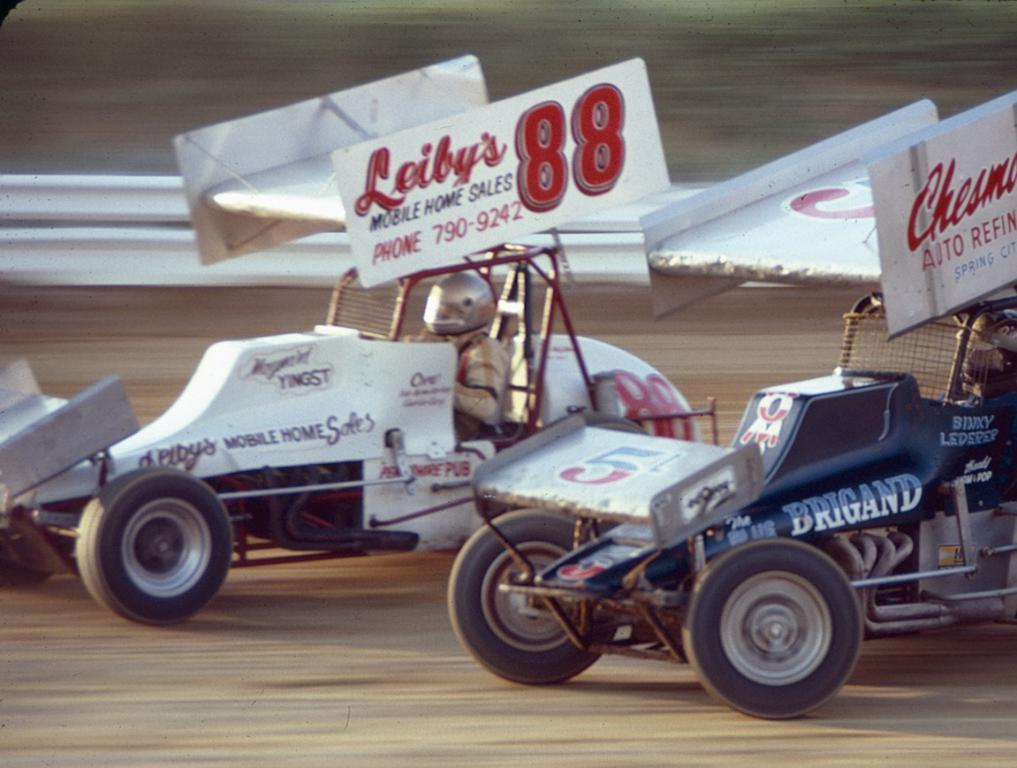What are the people in the image doing? The people in the image are driving cars. What safety feature can be seen in the image? There is a road safety barrier in the image. Can you describe the background of the image? The background of the image appears blurry. What type of sock is being crushed by the car in the image? There is no sock or car crushing a sock present in the image. What advice would you give to the son of the driver in the image? There is no information about the driver's son in the image, so it's not possible to give advice to him. 